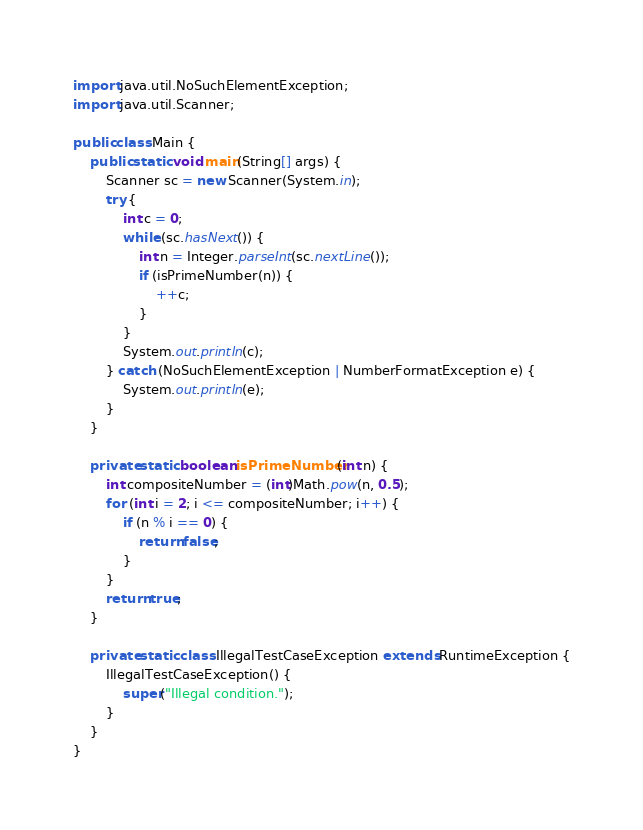Convert code to text. <code><loc_0><loc_0><loc_500><loc_500><_Java_>import java.util.NoSuchElementException;
import java.util.Scanner;

public class Main {
    public static void main(String[] args) {
        Scanner sc = new Scanner(System.in);
        try {
            int c = 0;
            while (sc.hasNext()) {
                int n = Integer.parseInt(sc.nextLine());
                if (isPrimeNumber(n)) {
                    ++c;
                }
            }
            System.out.println(c);
        } catch (NoSuchElementException | NumberFormatException e) {
            System.out.println(e);
        }
    }

    private static boolean isPrimeNumber(int n) {
        int compositeNumber = (int)Math.pow(n, 0.5);
        for (int i = 2; i <= compositeNumber; i++) {
            if (n % i == 0) {
                return false;
            }
        }
        return true;
    }

    private static class IllegalTestCaseException extends RuntimeException {
        IllegalTestCaseException() {
            super("Illegal condition.");
        }
    }
}

</code> 